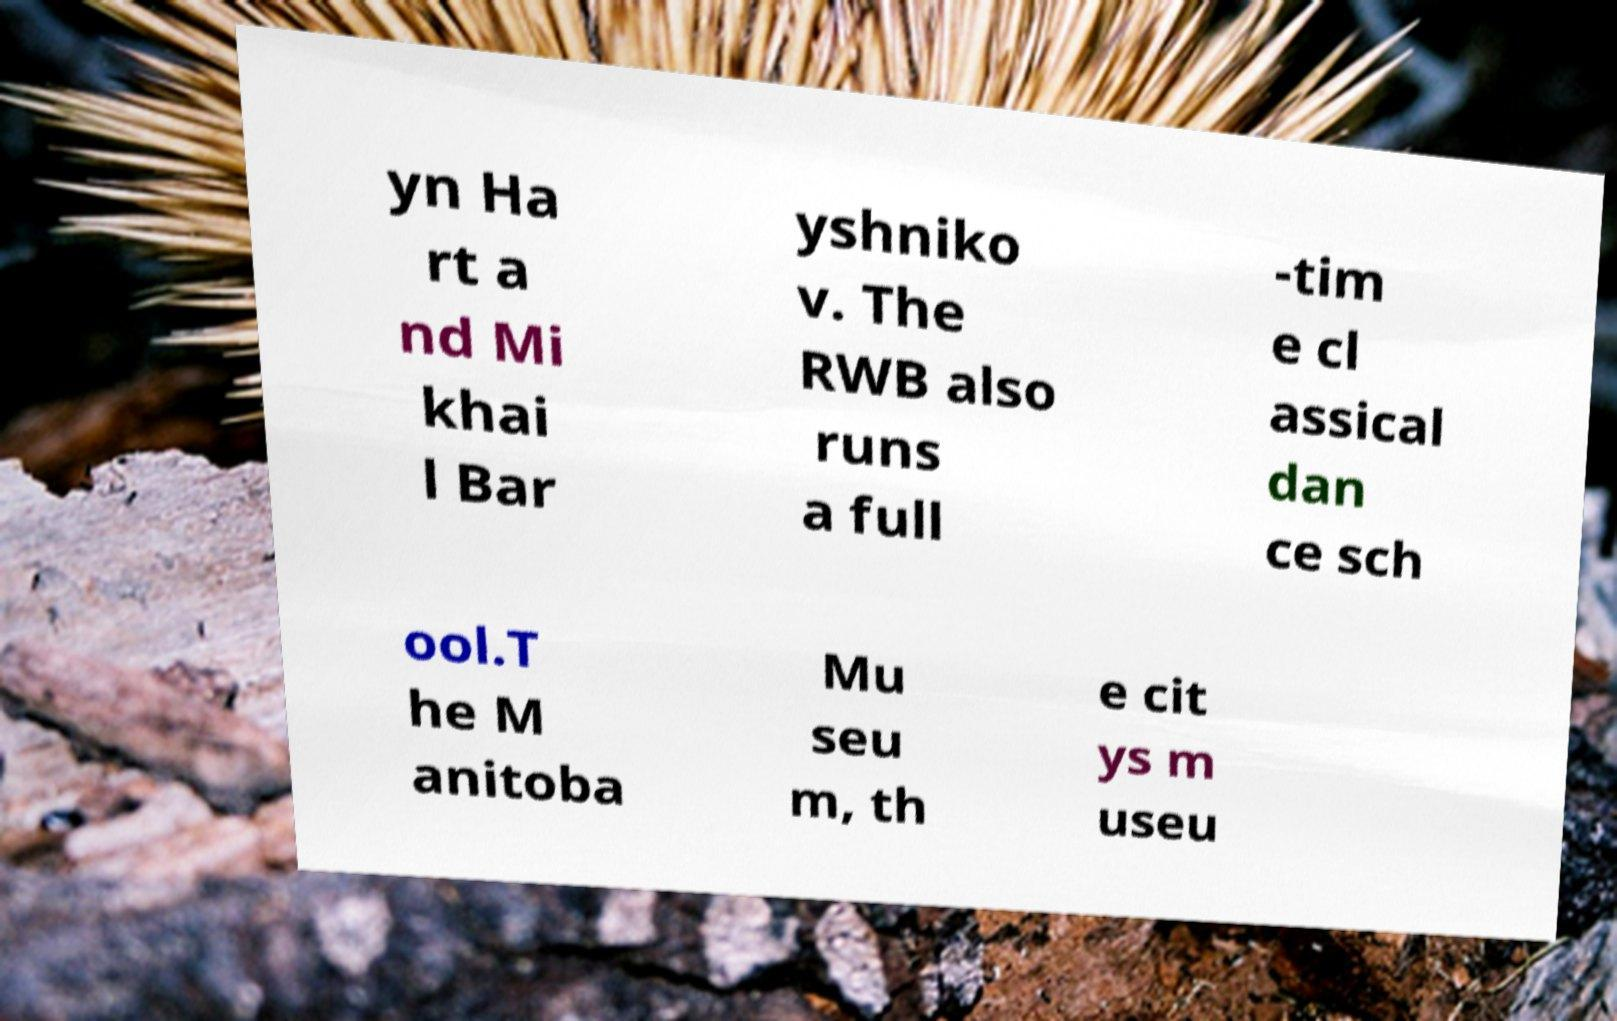I need the written content from this picture converted into text. Can you do that? yn Ha rt a nd Mi khai l Bar yshniko v. The RWB also runs a full -tim e cl assical dan ce sch ool.T he M anitoba Mu seu m, th e cit ys m useu 